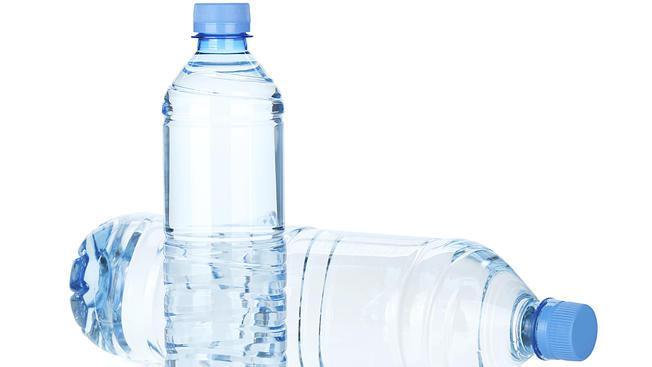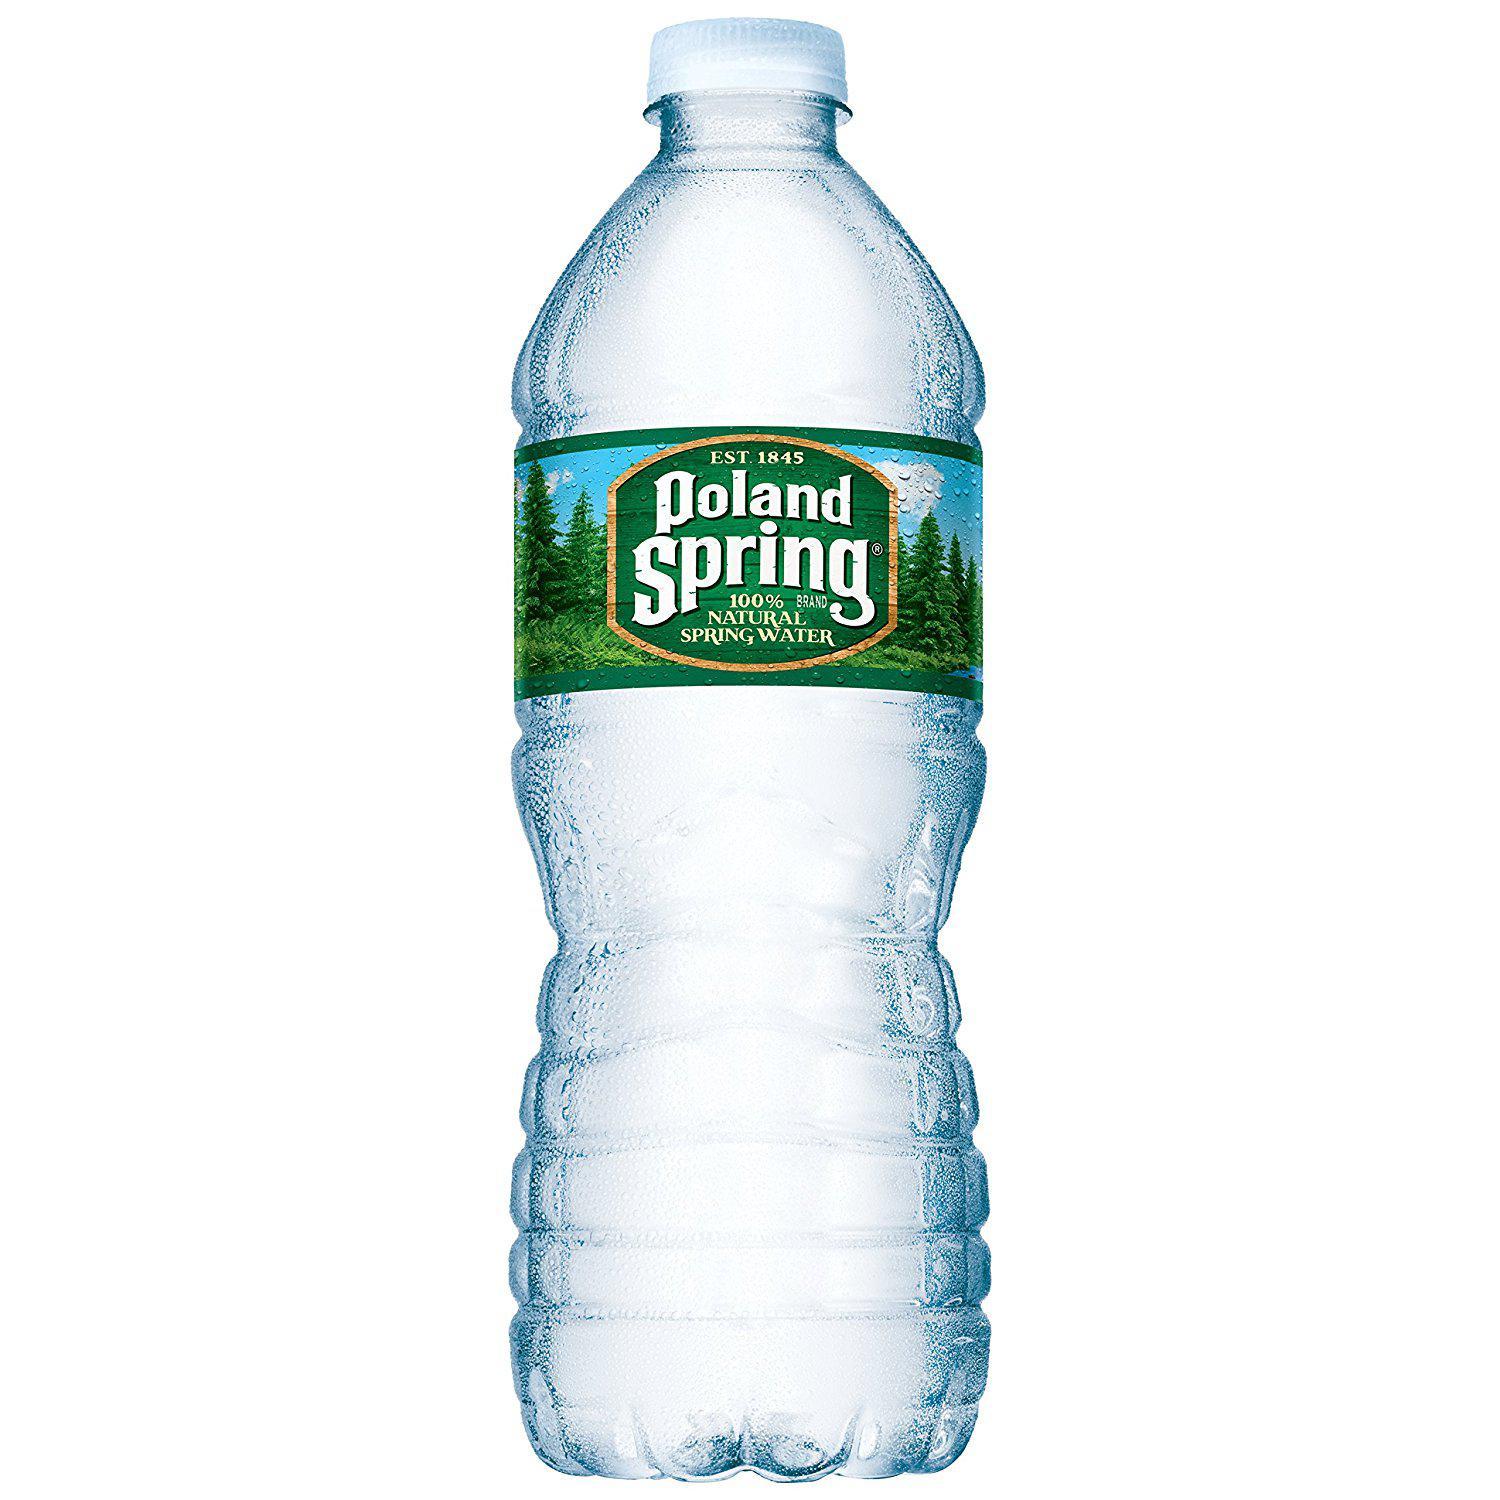The first image is the image on the left, the second image is the image on the right. Evaluate the accuracy of this statement regarding the images: "One image contains a single upright bottle with an indented 'hourglass' ribbed bottom, a paper label and a white lid, and the other image includes an upright blue-lidded label-less bottled with ribbing but no 'hourglass' indentation.". Is it true? Answer yes or no. Yes. The first image is the image on the left, the second image is the image on the right. Given the left and right images, does the statement "There are exactly two bottles." hold true? Answer yes or no. No. 